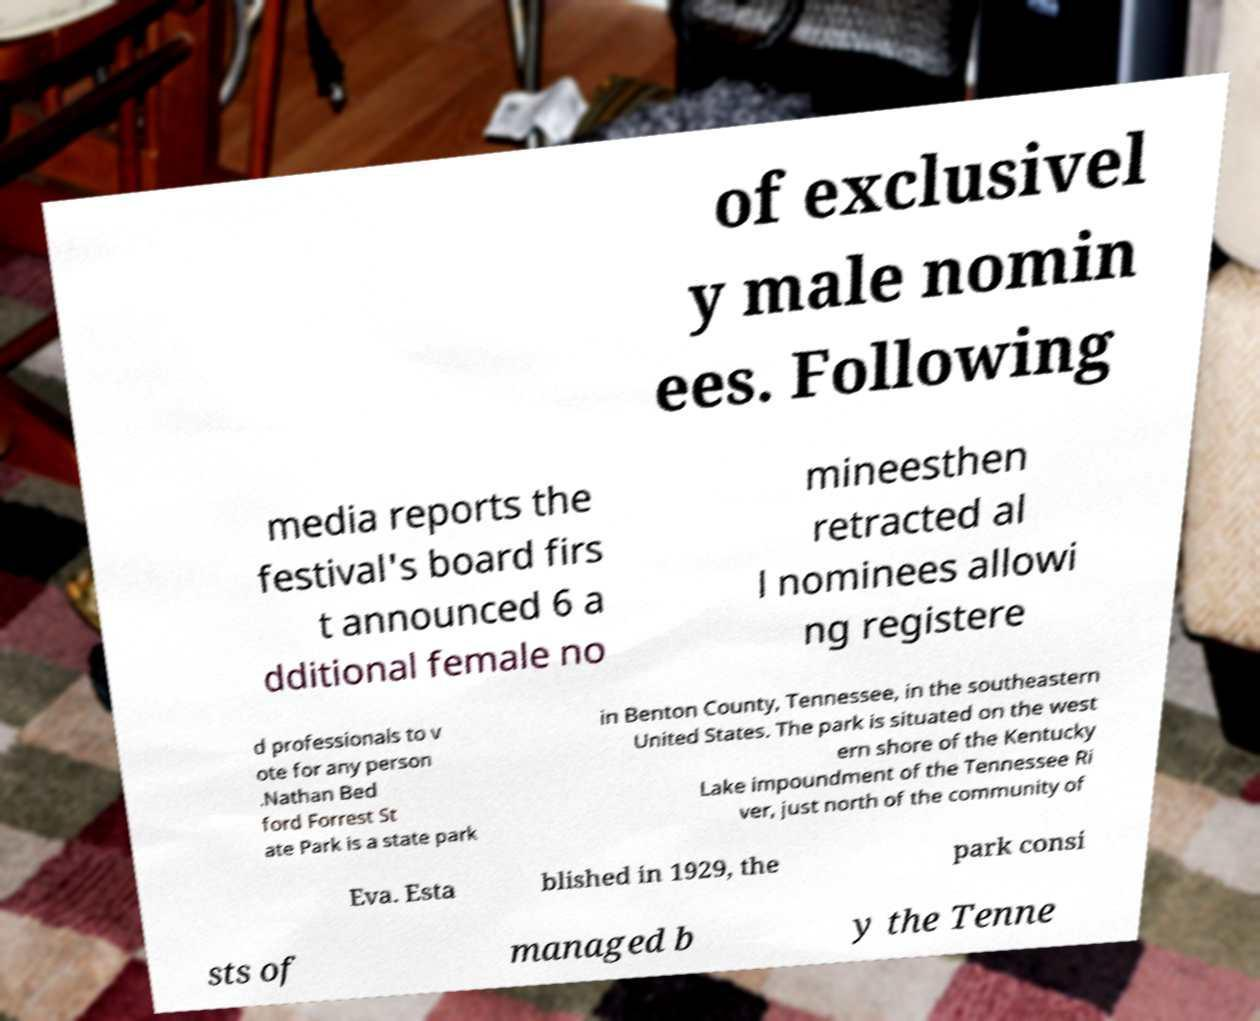There's text embedded in this image that I need extracted. Can you transcribe it verbatim? of exclusivel y male nomin ees. Following media reports the festival's board firs t announced 6 a dditional female no mineesthen retracted al l nominees allowi ng registere d professionals to v ote for any person .Nathan Bed ford Forrest St ate Park is a state park in Benton County, Tennessee, in the southeastern United States. The park is situated on the west ern shore of the Kentucky Lake impoundment of the Tennessee Ri ver, just north of the community of Eva. Esta blished in 1929, the park consi sts of managed b y the Tenne 